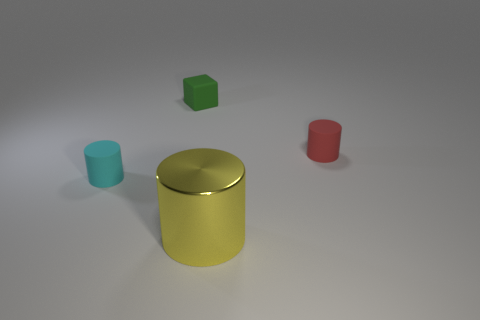Subtract all big yellow cylinders. How many cylinders are left? 2 Add 4 metal cylinders. How many objects exist? 8 Subtract all gray cylinders. Subtract all green spheres. How many cylinders are left? 3 Subtract all cylinders. How many objects are left? 1 Add 1 large gray cubes. How many large gray cubes exist? 1 Subtract 0 purple balls. How many objects are left? 4 Subtract all purple cylinders. Subtract all blocks. How many objects are left? 3 Add 4 tiny green things. How many tiny green things are left? 5 